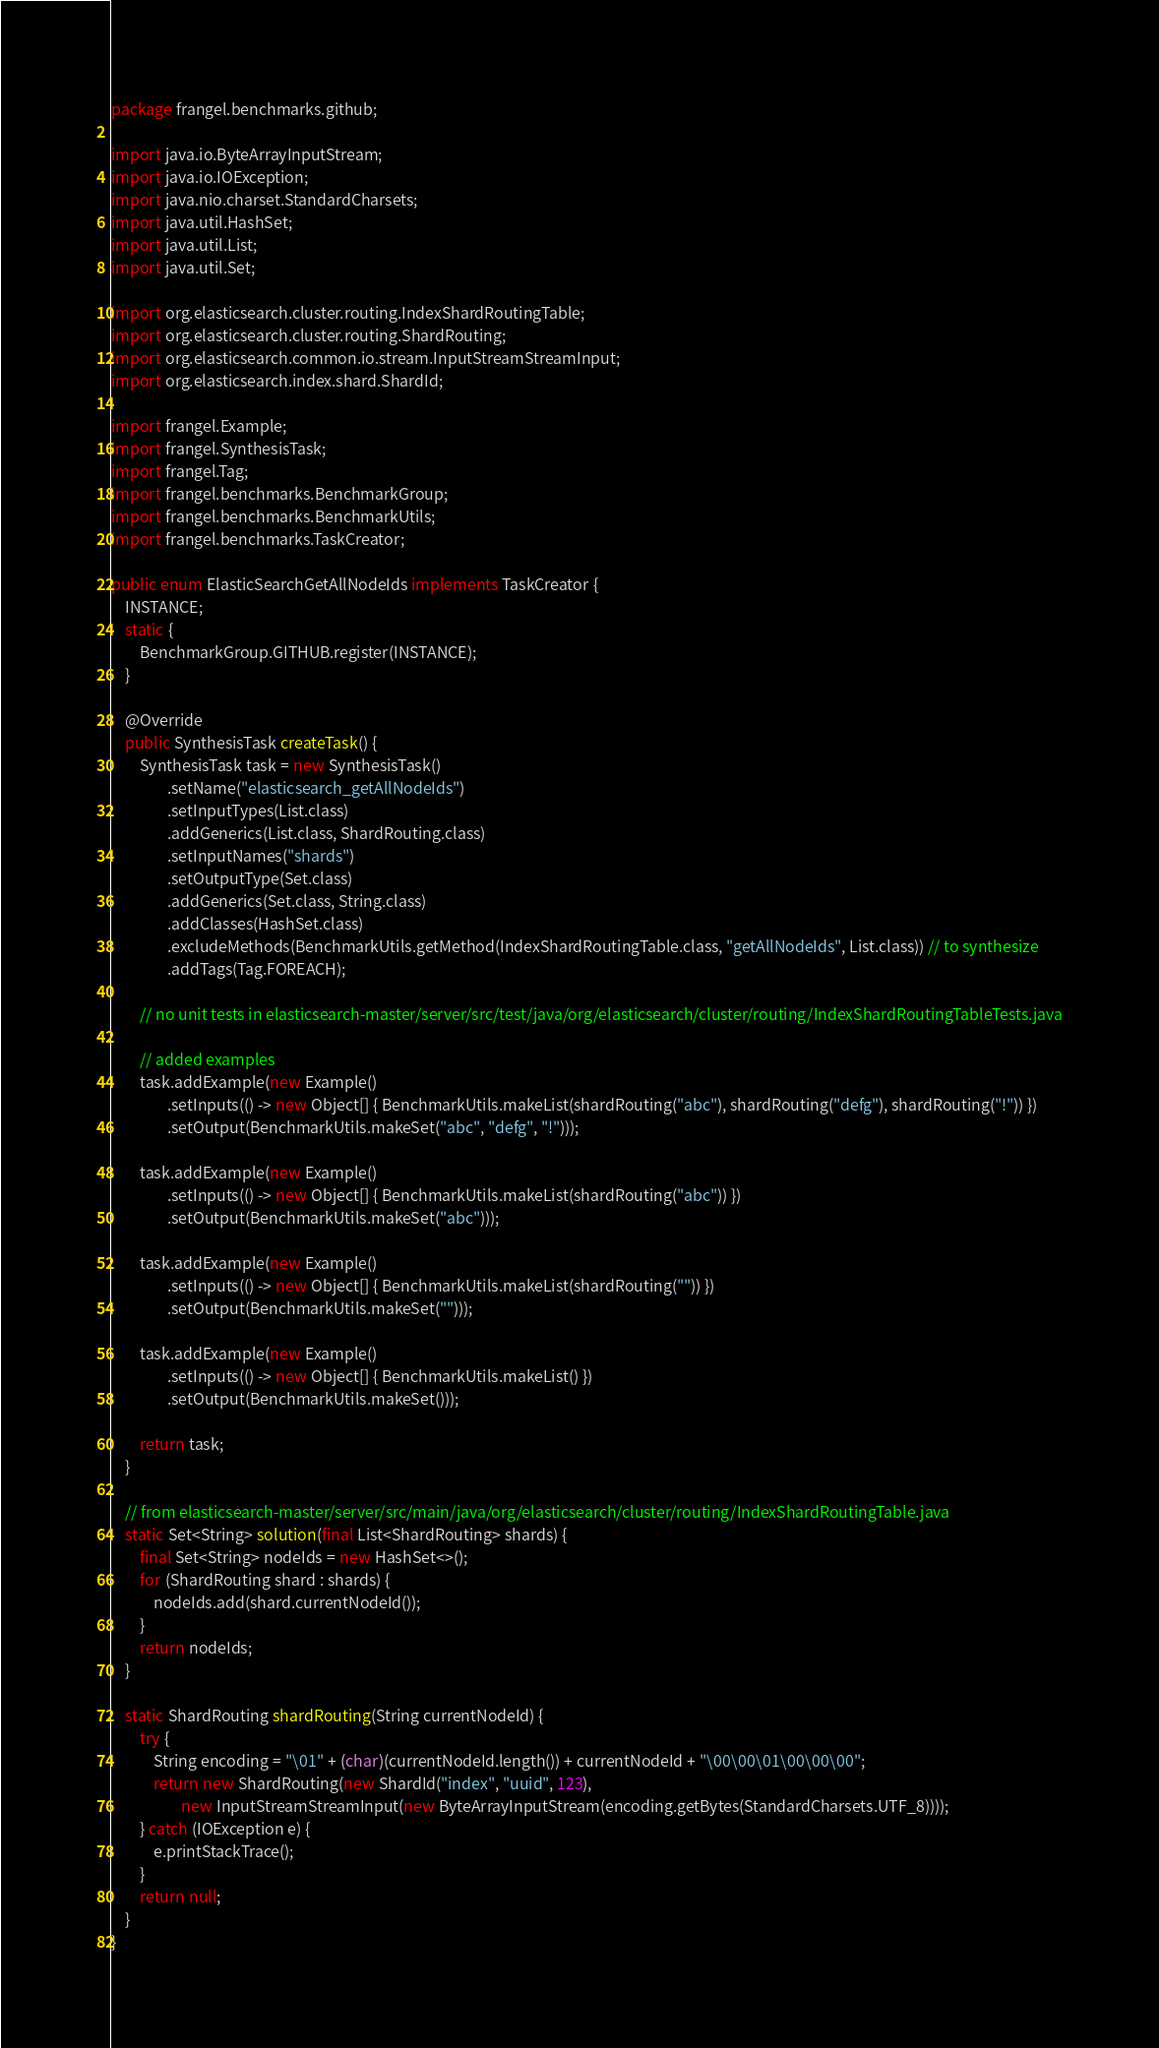<code> <loc_0><loc_0><loc_500><loc_500><_Java_>package frangel.benchmarks.github;

import java.io.ByteArrayInputStream;
import java.io.IOException;
import java.nio.charset.StandardCharsets;
import java.util.HashSet;
import java.util.List;
import java.util.Set;

import org.elasticsearch.cluster.routing.IndexShardRoutingTable;
import org.elasticsearch.cluster.routing.ShardRouting;
import org.elasticsearch.common.io.stream.InputStreamStreamInput;
import org.elasticsearch.index.shard.ShardId;

import frangel.Example;
import frangel.SynthesisTask;
import frangel.Tag;
import frangel.benchmarks.BenchmarkGroup;
import frangel.benchmarks.BenchmarkUtils;
import frangel.benchmarks.TaskCreator;

public enum ElasticSearchGetAllNodeIds implements TaskCreator {
    INSTANCE;
    static {
        BenchmarkGroup.GITHUB.register(INSTANCE);
    }

    @Override
    public SynthesisTask createTask() {
        SynthesisTask task = new SynthesisTask()
                .setName("elasticsearch_getAllNodeIds")
                .setInputTypes(List.class)
                .addGenerics(List.class, ShardRouting.class)
                .setInputNames("shards")
                .setOutputType(Set.class)
                .addGenerics(Set.class, String.class)
                .addClasses(HashSet.class)
                .excludeMethods(BenchmarkUtils.getMethod(IndexShardRoutingTable.class, "getAllNodeIds", List.class)) // to synthesize
                .addTags(Tag.FOREACH);

        // no unit tests in elasticsearch-master/server/src/test/java/org/elasticsearch/cluster/routing/IndexShardRoutingTableTests.java

        // added examples
        task.addExample(new Example()
                .setInputs(() -> new Object[] { BenchmarkUtils.makeList(shardRouting("abc"), shardRouting("defg"), shardRouting("!")) })
                .setOutput(BenchmarkUtils.makeSet("abc", "defg", "!")));

        task.addExample(new Example()
                .setInputs(() -> new Object[] { BenchmarkUtils.makeList(shardRouting("abc")) })
                .setOutput(BenchmarkUtils.makeSet("abc")));

        task.addExample(new Example()
                .setInputs(() -> new Object[] { BenchmarkUtils.makeList(shardRouting("")) })
                .setOutput(BenchmarkUtils.makeSet("")));

        task.addExample(new Example()
                .setInputs(() -> new Object[] { BenchmarkUtils.makeList() })
                .setOutput(BenchmarkUtils.makeSet()));

        return task;
    }

    // from elasticsearch-master/server/src/main/java/org/elasticsearch/cluster/routing/IndexShardRoutingTable.java
    static Set<String> solution(final List<ShardRouting> shards) {
        final Set<String> nodeIds = new HashSet<>();
        for (ShardRouting shard : shards) {
            nodeIds.add(shard.currentNodeId());
        }
        return nodeIds;
    }

    static ShardRouting shardRouting(String currentNodeId) {
        try {
            String encoding = "\01" + (char)(currentNodeId.length()) + currentNodeId + "\00\00\01\00\00\00";
            return new ShardRouting(new ShardId("index", "uuid", 123),
                    new InputStreamStreamInput(new ByteArrayInputStream(encoding.getBytes(StandardCharsets.UTF_8))));
        } catch (IOException e) {
            e.printStackTrace();
        }
        return null;
    }
}
</code> 